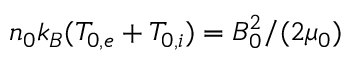<formula> <loc_0><loc_0><loc_500><loc_500>{ n _ { 0 } k _ { B } ( T _ { 0 , e } + T _ { 0 , i } ) = B _ { 0 } ^ { 2 } / ( 2 \mu _ { 0 } ) }</formula> 